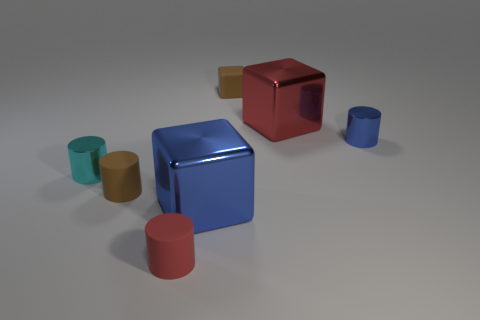Is there anything else that is the same material as the cyan cylinder?
Make the answer very short. Yes. Are there fewer small gray cylinders than small blue objects?
Your answer should be compact. Yes. What number of blue metal objects are the same shape as the red matte thing?
Offer a very short reply. 1. How many green things are matte cylinders or rubber objects?
Your response must be concise. 0. There is a red thing right of the brown rubber object behind the tiny cyan metal thing; how big is it?
Offer a very short reply. Large. There is a brown thing that is the same shape as the tiny blue shiny thing; what material is it?
Ensure brevity in your answer.  Rubber. What number of blue shiny things are the same size as the rubber cube?
Offer a very short reply. 1. Do the red metallic cube and the blue block have the same size?
Offer a terse response. Yes. What is the size of the metallic object that is both to the left of the tiny rubber block and to the right of the tiny red object?
Provide a succinct answer. Large. Are there more red objects that are in front of the red metallic cube than red rubber things behind the blue block?
Ensure brevity in your answer.  Yes. 